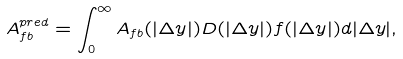<formula> <loc_0><loc_0><loc_500><loc_500>A _ { f b } ^ { p r e d } = \int _ { 0 } ^ { \infty } A _ { f b } ( | \Delta y | ) D ( | \Delta y | ) f ( | \Delta y | ) d | \Delta y | ,</formula> 